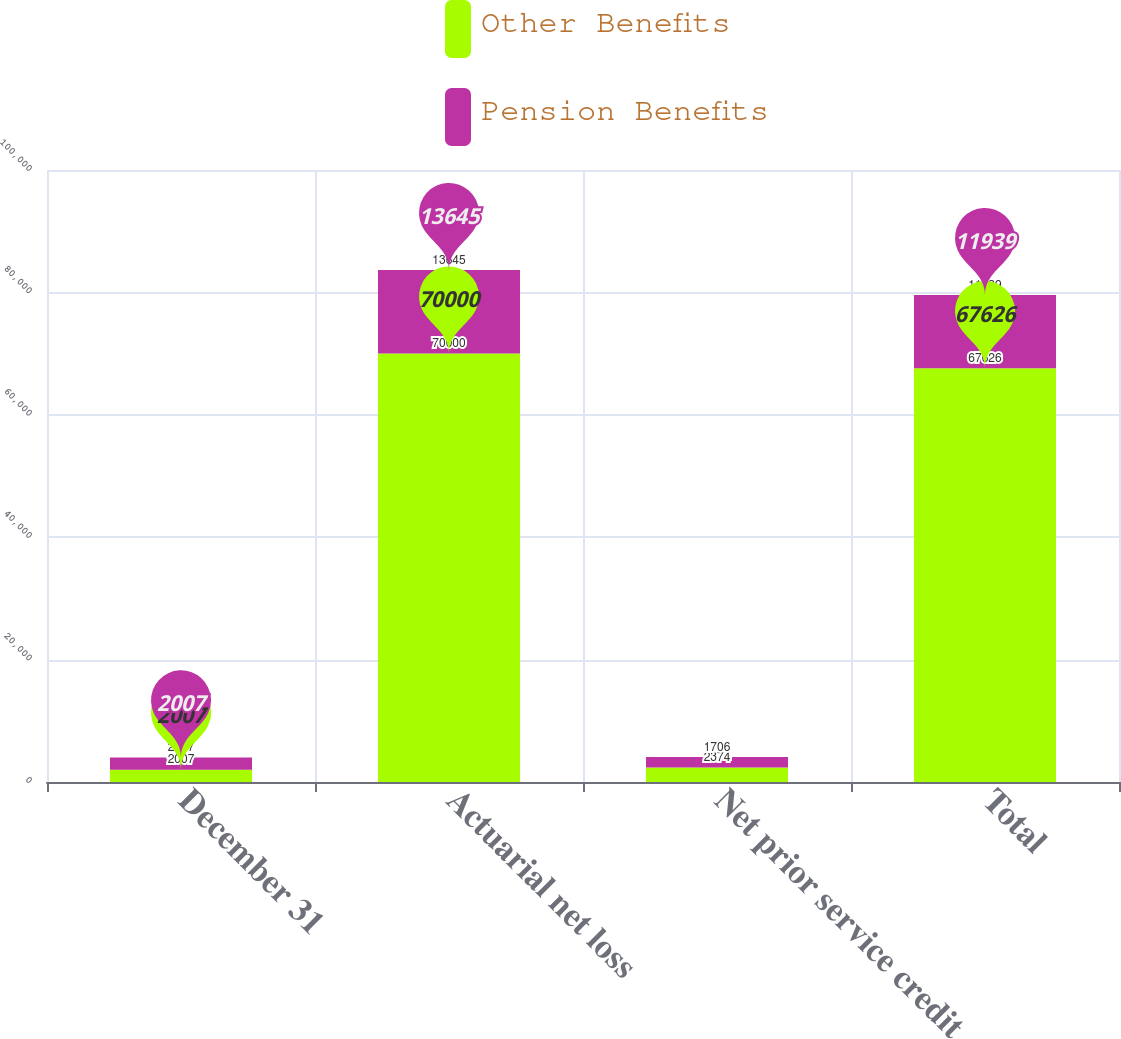Convert chart to OTSL. <chart><loc_0><loc_0><loc_500><loc_500><stacked_bar_chart><ecel><fcel>December 31<fcel>Actuarial net loss<fcel>Net prior service credit<fcel>Total<nl><fcel>Other Benefits<fcel>2007<fcel>70000<fcel>2374<fcel>67626<nl><fcel>Pension Benefits<fcel>2007<fcel>13645<fcel>1706<fcel>11939<nl></chart> 